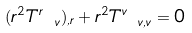<formula> <loc_0><loc_0><loc_500><loc_500>( r ^ { 2 } T ^ { r } _ { \ v } ) _ { , r } + r ^ { 2 } T ^ { v } _ { \ v , v } = 0</formula> 